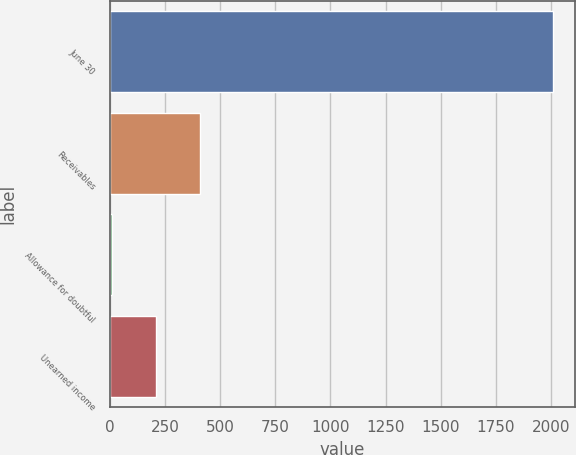Convert chart. <chart><loc_0><loc_0><loc_500><loc_500><bar_chart><fcel>June 30<fcel>Receivables<fcel>Allowance for doubtful<fcel>Unearned income<nl><fcel>2007<fcel>408.04<fcel>8.3<fcel>208.17<nl></chart> 